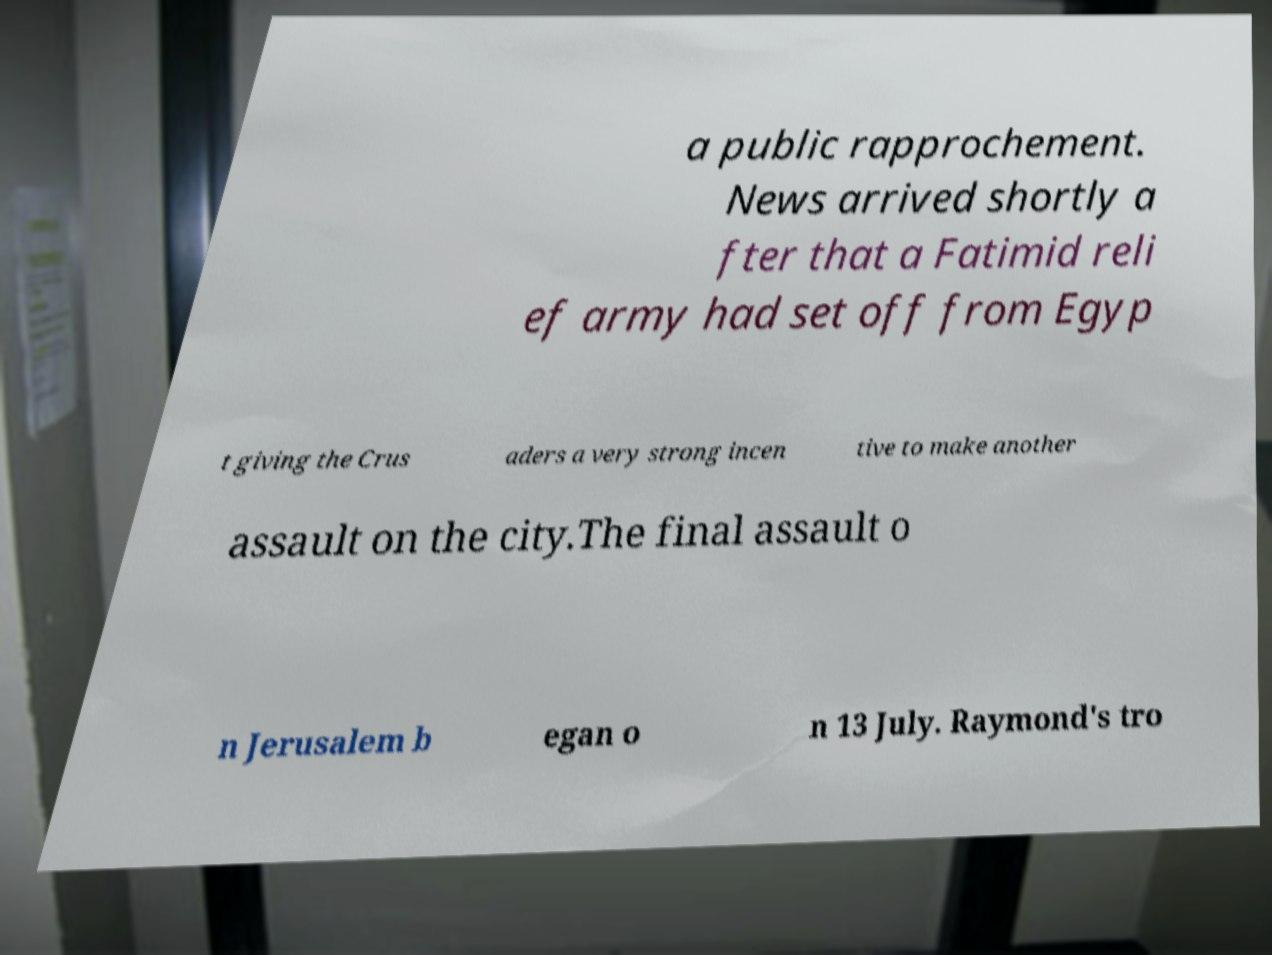I need the written content from this picture converted into text. Can you do that? a public rapprochement. News arrived shortly a fter that a Fatimid reli ef army had set off from Egyp t giving the Crus aders a very strong incen tive to make another assault on the city.The final assault o n Jerusalem b egan o n 13 July. Raymond's tro 